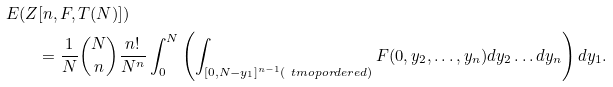<formula> <loc_0><loc_0><loc_500><loc_500>E ( Z & [ n , F , T ( N ) ] ) \\ & = \frac { 1 } { N } \binom { N } { n } \frac { n ! } { N ^ { n } } \int _ { 0 } ^ { N } \left ( \int _ { [ 0 , N - y _ { 1 } ] ^ { n - 1 } ( \ t m o p { o r d e r e d } ) } F ( 0 , y _ { 2 } , \dots , y _ { n } ) d y _ { 2 } \dots d y _ { n } \right ) d y _ { 1 } . \</formula> 